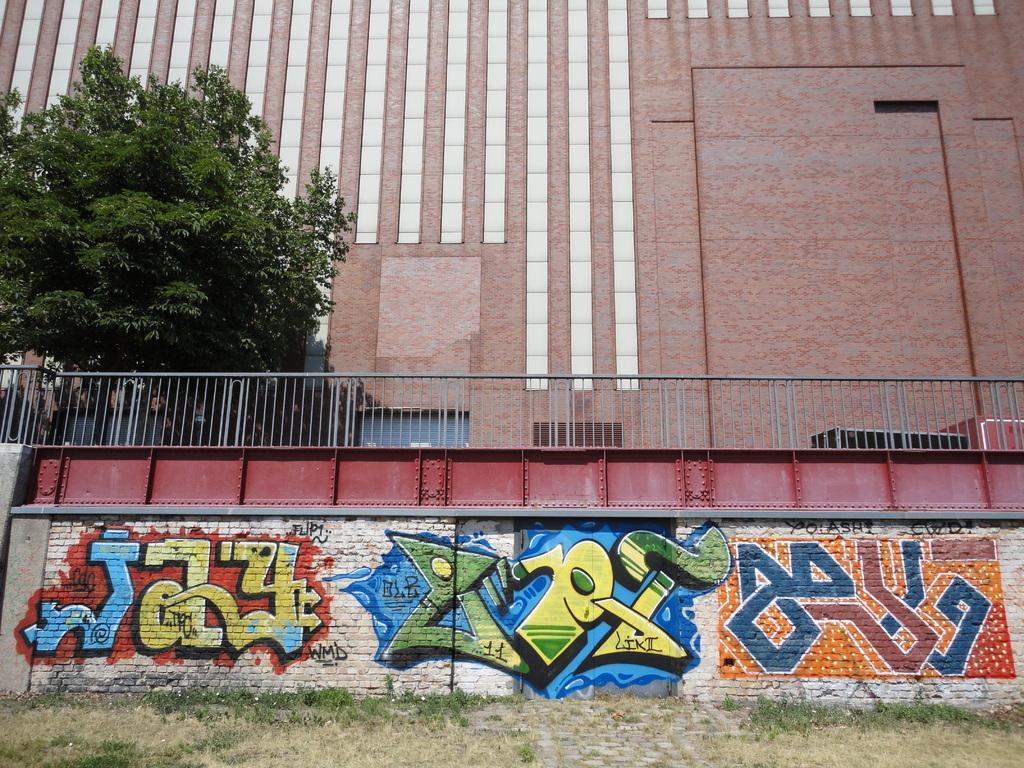In one or two sentences, can you explain what this image depicts? In this picture we can see grass on the ground, beside this ground we can see a wall with a painting on it and in the background we can see a building, tree. 